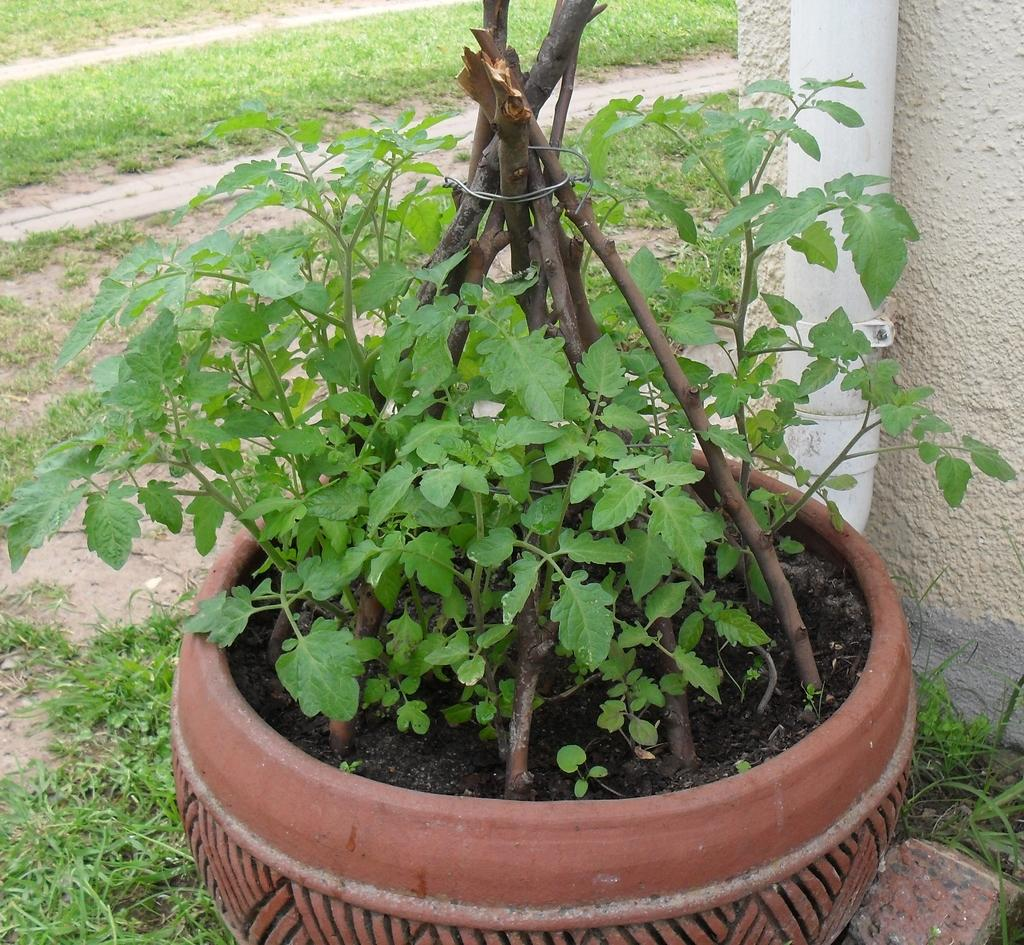What type of plant can be seen in the image? There is a potted plant in the image. What is attached to the wall in the image? There is a pipeline attached to the wall in the image. What type of vegetation is visible near the wall in the image? There is grass beside the wall in the image. Where is the pocket located in the image? There is no pocket present in the image. What type of meeting is taking place in the image? There is no meeting depicted in the image. 